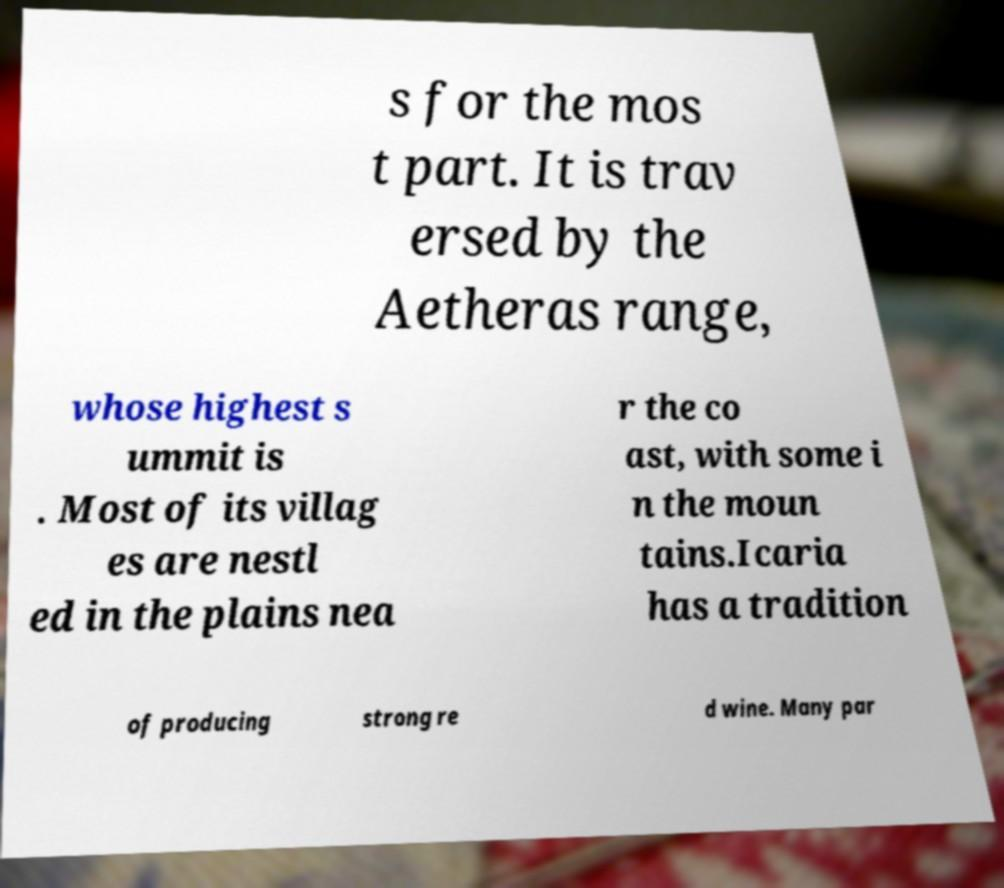I need the written content from this picture converted into text. Can you do that? s for the mos t part. It is trav ersed by the Aetheras range, whose highest s ummit is . Most of its villag es are nestl ed in the plains nea r the co ast, with some i n the moun tains.Icaria has a tradition of producing strong re d wine. Many par 